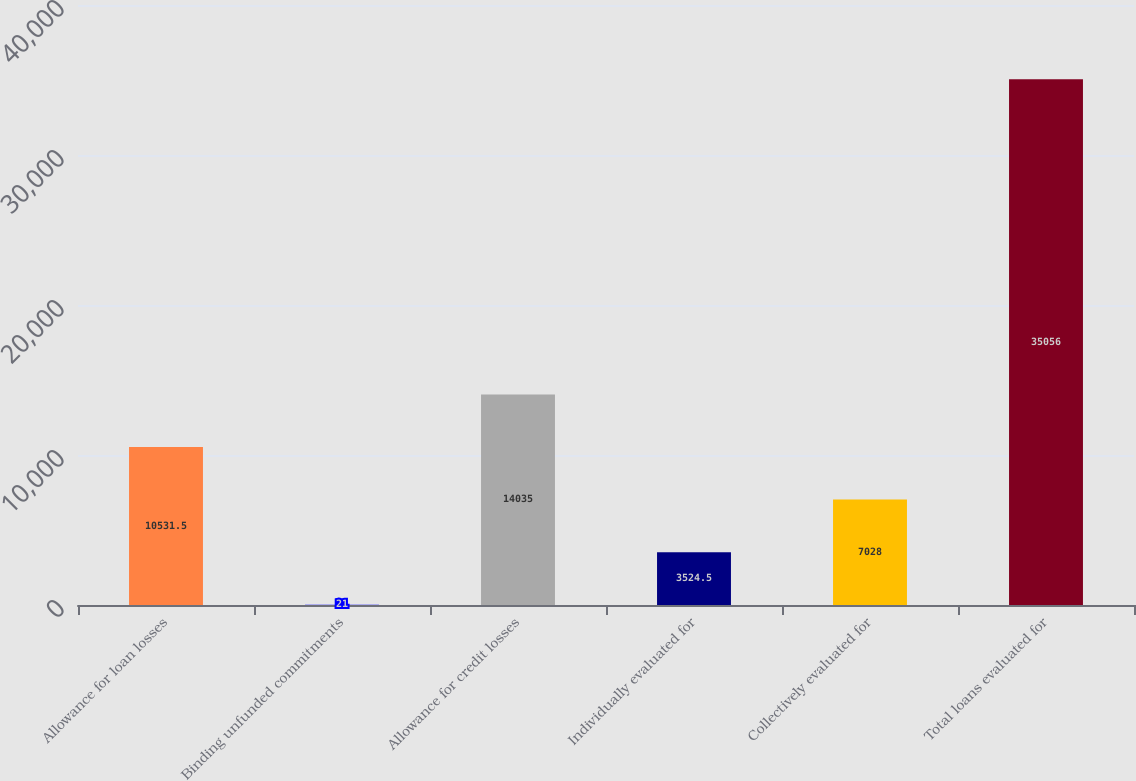Convert chart to OTSL. <chart><loc_0><loc_0><loc_500><loc_500><bar_chart><fcel>Allowance for loan losses<fcel>Binding unfunded commitments<fcel>Allowance for credit losses<fcel>Individually evaluated for<fcel>Collectively evaluated for<fcel>Total loans evaluated for<nl><fcel>10531.5<fcel>21<fcel>14035<fcel>3524.5<fcel>7028<fcel>35056<nl></chart> 